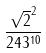Convert formula to latex. <formula><loc_0><loc_0><loc_500><loc_500>\frac { \sqrt { 2 } ^ { 2 } } { 2 4 3 ^ { 1 0 } }</formula> 